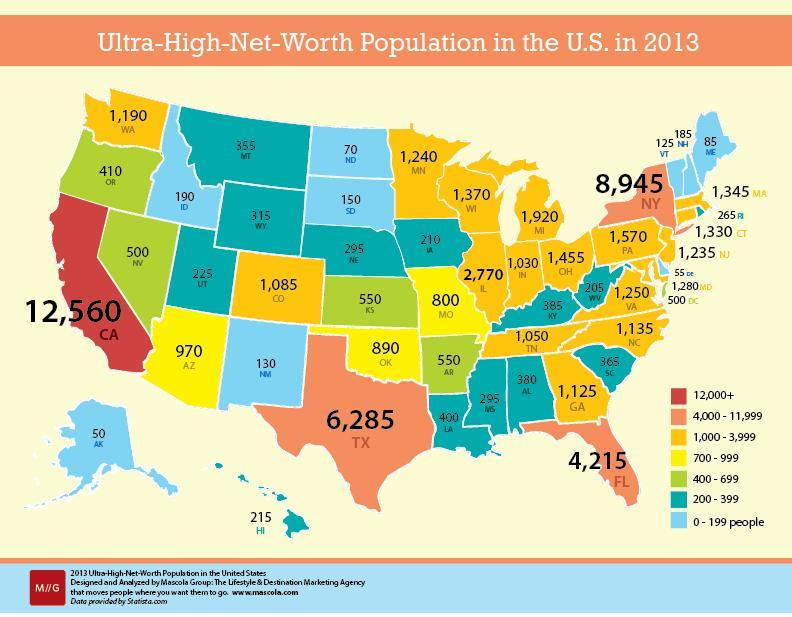How many states have an Ultra-High-Net-Worth Population of 12000+?
Answer the question with a short phrase. 1 How many states have an Ultra-High-Net-Worth Population of 4000-11999? 4 